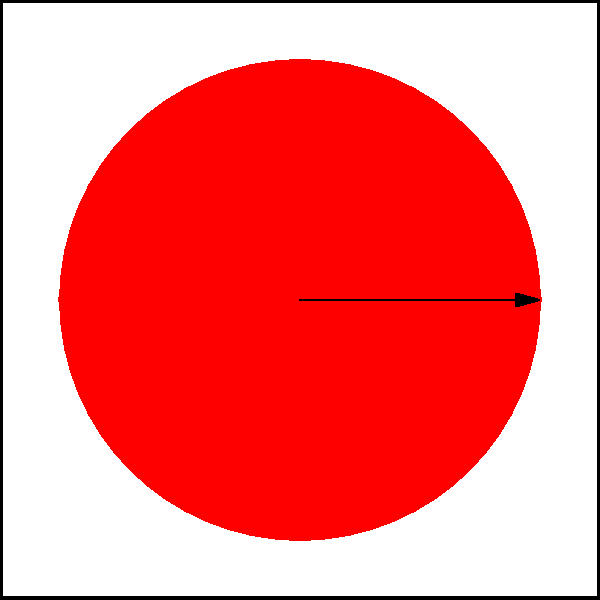In the iconic Ghostbusters logo, as seen in the 1984 film starring Sigourney Weaver, the ghost figure is enclosed within a prohibition sign. Considering the rotational symmetry of this logo, what is the order of rotational symmetry for the complete Ghostbusters emblem? To determine the order of rotational symmetry for the Ghostbusters logo, we need to follow these steps:

1. Understand rotational symmetry: An object has rotational symmetry if it looks the same after being rotated by a certain angle less than 360°.

2. Analyze the logo components:
   a) The ghost figure: Asymmetrical, no rotational symmetry on its own.
   b) The prohibition sign: Circle with a diagonal line, has 2-fold rotational symmetry (180° rotation).

3. Consider the complete logo:
   The asymmetrical ghost within the symmetrical prohibition sign breaks the 2-fold symmetry of the circle.

4. Rotate the logo:
   The logo only looks identical to its original position after a full 360° rotation.

5. Calculate the order of rotational symmetry:
   The order is determined by 360° divided by the smallest angle of rotation that brings the logo back to its original appearance.
   In this case: 360° ÷ 360° = 1

Therefore, the Ghostbusters logo has an order of rotational symmetry of 1, meaning it has no rotational symmetry other than a full 360° rotation.
Answer: 1 